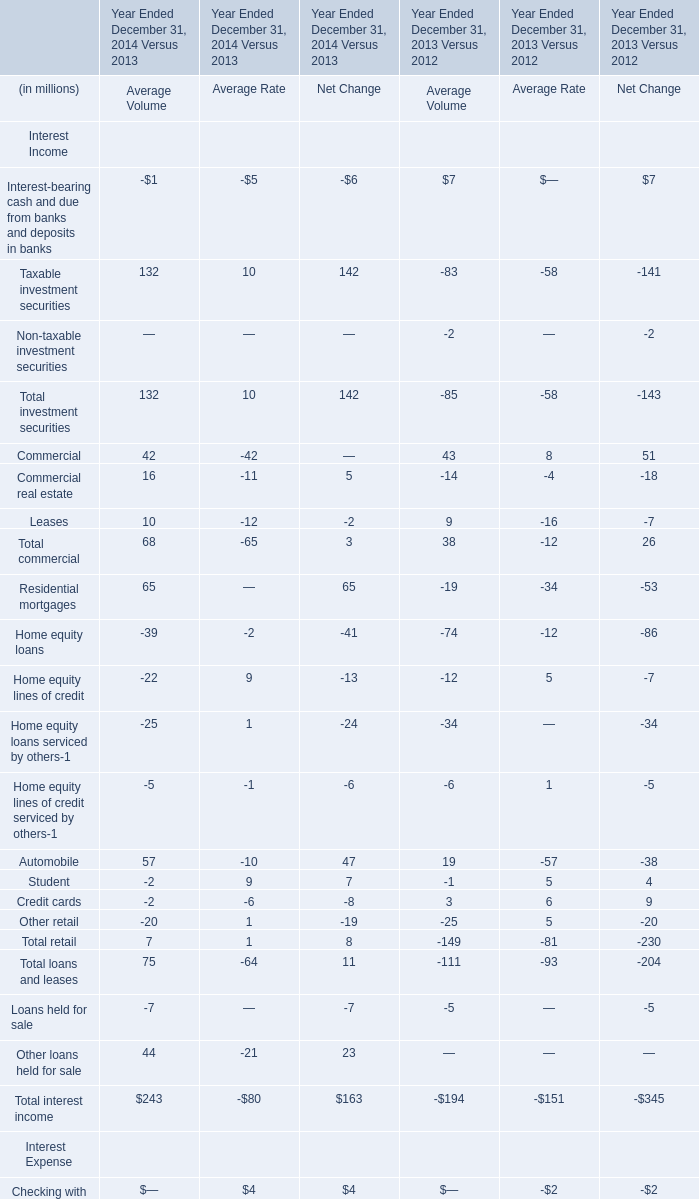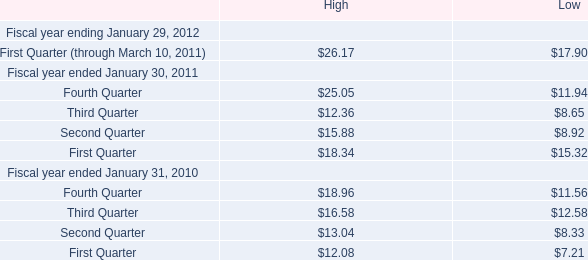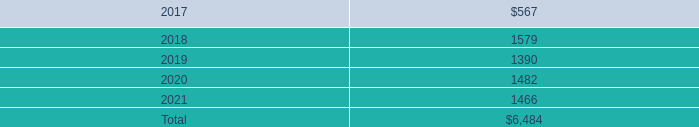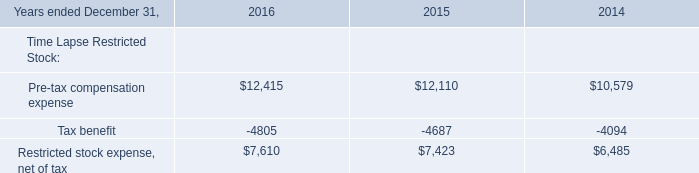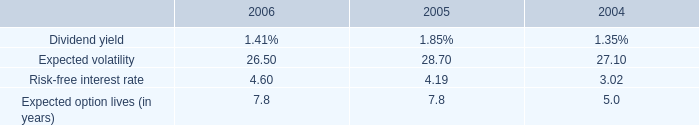by what percent did the risk free interest rate increase between 2004 and 2006? 
Computations: ((4.60 - 3.02) / 3.02)
Answer: 0.52318. 